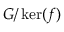Convert formula to latex. <formula><loc_0><loc_0><loc_500><loc_500>G / \ker ( f )</formula> 